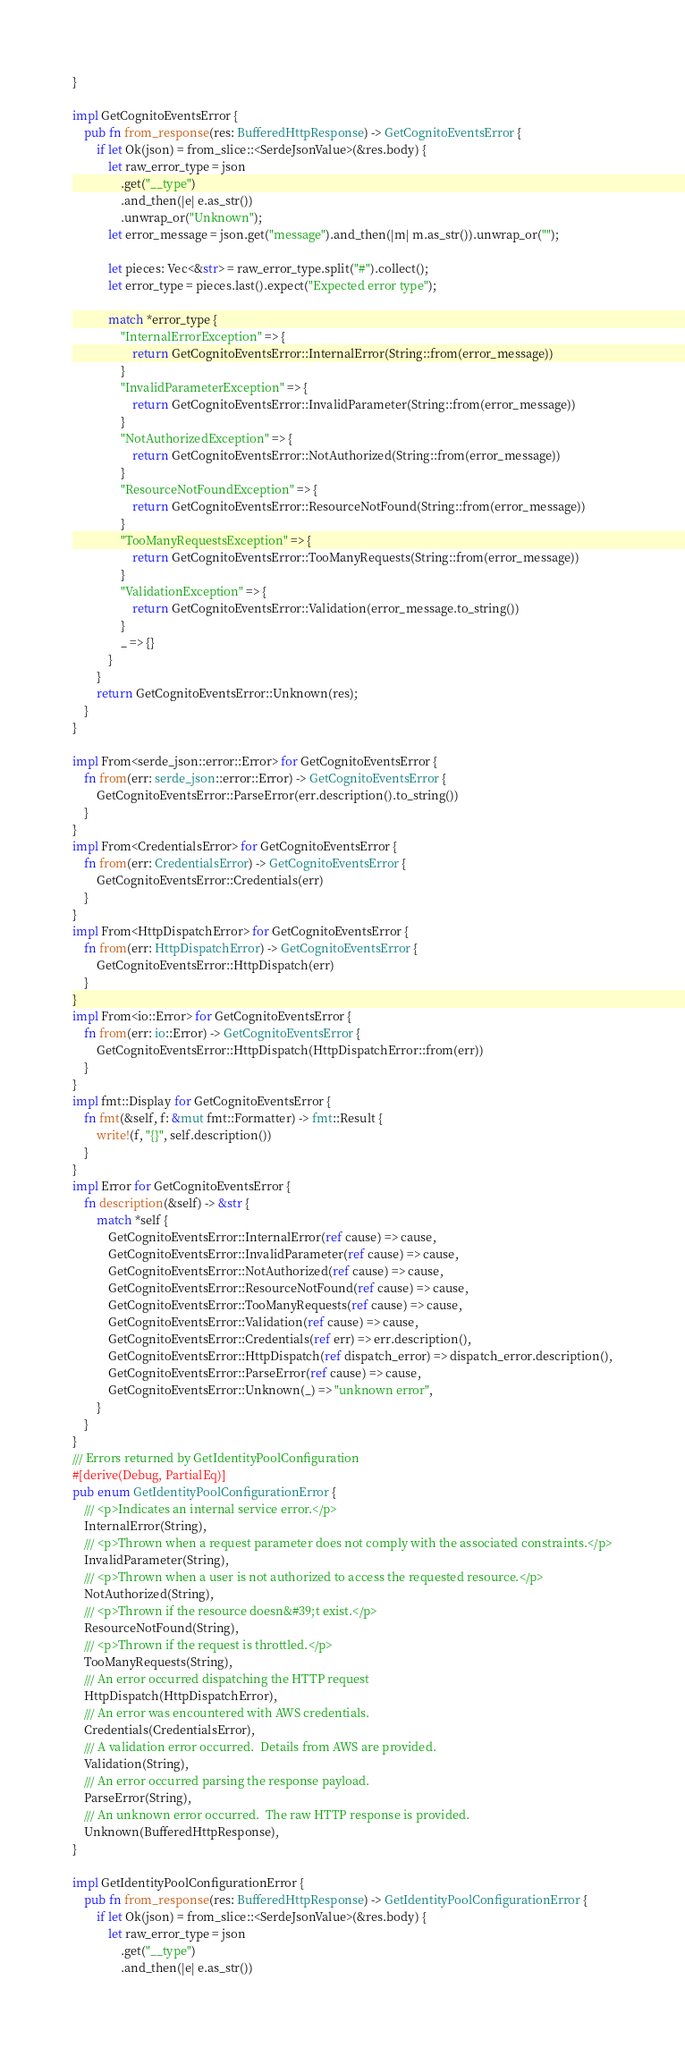Convert code to text. <code><loc_0><loc_0><loc_500><loc_500><_Rust_>}

impl GetCognitoEventsError {
    pub fn from_response(res: BufferedHttpResponse) -> GetCognitoEventsError {
        if let Ok(json) = from_slice::<SerdeJsonValue>(&res.body) {
            let raw_error_type = json
                .get("__type")
                .and_then(|e| e.as_str())
                .unwrap_or("Unknown");
            let error_message = json.get("message").and_then(|m| m.as_str()).unwrap_or("");

            let pieces: Vec<&str> = raw_error_type.split("#").collect();
            let error_type = pieces.last().expect("Expected error type");

            match *error_type {
                "InternalErrorException" => {
                    return GetCognitoEventsError::InternalError(String::from(error_message))
                }
                "InvalidParameterException" => {
                    return GetCognitoEventsError::InvalidParameter(String::from(error_message))
                }
                "NotAuthorizedException" => {
                    return GetCognitoEventsError::NotAuthorized(String::from(error_message))
                }
                "ResourceNotFoundException" => {
                    return GetCognitoEventsError::ResourceNotFound(String::from(error_message))
                }
                "TooManyRequestsException" => {
                    return GetCognitoEventsError::TooManyRequests(String::from(error_message))
                }
                "ValidationException" => {
                    return GetCognitoEventsError::Validation(error_message.to_string())
                }
                _ => {}
            }
        }
        return GetCognitoEventsError::Unknown(res);
    }
}

impl From<serde_json::error::Error> for GetCognitoEventsError {
    fn from(err: serde_json::error::Error) -> GetCognitoEventsError {
        GetCognitoEventsError::ParseError(err.description().to_string())
    }
}
impl From<CredentialsError> for GetCognitoEventsError {
    fn from(err: CredentialsError) -> GetCognitoEventsError {
        GetCognitoEventsError::Credentials(err)
    }
}
impl From<HttpDispatchError> for GetCognitoEventsError {
    fn from(err: HttpDispatchError) -> GetCognitoEventsError {
        GetCognitoEventsError::HttpDispatch(err)
    }
}
impl From<io::Error> for GetCognitoEventsError {
    fn from(err: io::Error) -> GetCognitoEventsError {
        GetCognitoEventsError::HttpDispatch(HttpDispatchError::from(err))
    }
}
impl fmt::Display for GetCognitoEventsError {
    fn fmt(&self, f: &mut fmt::Formatter) -> fmt::Result {
        write!(f, "{}", self.description())
    }
}
impl Error for GetCognitoEventsError {
    fn description(&self) -> &str {
        match *self {
            GetCognitoEventsError::InternalError(ref cause) => cause,
            GetCognitoEventsError::InvalidParameter(ref cause) => cause,
            GetCognitoEventsError::NotAuthorized(ref cause) => cause,
            GetCognitoEventsError::ResourceNotFound(ref cause) => cause,
            GetCognitoEventsError::TooManyRequests(ref cause) => cause,
            GetCognitoEventsError::Validation(ref cause) => cause,
            GetCognitoEventsError::Credentials(ref err) => err.description(),
            GetCognitoEventsError::HttpDispatch(ref dispatch_error) => dispatch_error.description(),
            GetCognitoEventsError::ParseError(ref cause) => cause,
            GetCognitoEventsError::Unknown(_) => "unknown error",
        }
    }
}
/// Errors returned by GetIdentityPoolConfiguration
#[derive(Debug, PartialEq)]
pub enum GetIdentityPoolConfigurationError {
    /// <p>Indicates an internal service error.</p>
    InternalError(String),
    /// <p>Thrown when a request parameter does not comply with the associated constraints.</p>
    InvalidParameter(String),
    /// <p>Thrown when a user is not authorized to access the requested resource.</p>
    NotAuthorized(String),
    /// <p>Thrown if the resource doesn&#39;t exist.</p>
    ResourceNotFound(String),
    /// <p>Thrown if the request is throttled.</p>
    TooManyRequests(String),
    /// An error occurred dispatching the HTTP request
    HttpDispatch(HttpDispatchError),
    /// An error was encountered with AWS credentials.
    Credentials(CredentialsError),
    /// A validation error occurred.  Details from AWS are provided.
    Validation(String),
    /// An error occurred parsing the response payload.
    ParseError(String),
    /// An unknown error occurred.  The raw HTTP response is provided.
    Unknown(BufferedHttpResponse),
}

impl GetIdentityPoolConfigurationError {
    pub fn from_response(res: BufferedHttpResponse) -> GetIdentityPoolConfigurationError {
        if let Ok(json) = from_slice::<SerdeJsonValue>(&res.body) {
            let raw_error_type = json
                .get("__type")
                .and_then(|e| e.as_str())</code> 